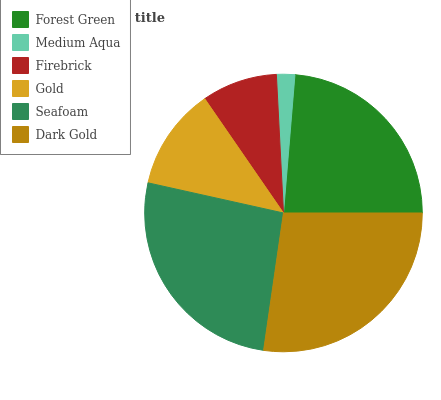Is Medium Aqua the minimum?
Answer yes or no. Yes. Is Dark Gold the maximum?
Answer yes or no. Yes. Is Firebrick the minimum?
Answer yes or no. No. Is Firebrick the maximum?
Answer yes or no. No. Is Firebrick greater than Medium Aqua?
Answer yes or no. Yes. Is Medium Aqua less than Firebrick?
Answer yes or no. Yes. Is Medium Aqua greater than Firebrick?
Answer yes or no. No. Is Firebrick less than Medium Aqua?
Answer yes or no. No. Is Forest Green the high median?
Answer yes or no. Yes. Is Gold the low median?
Answer yes or no. Yes. Is Gold the high median?
Answer yes or no. No. Is Dark Gold the low median?
Answer yes or no. No. 